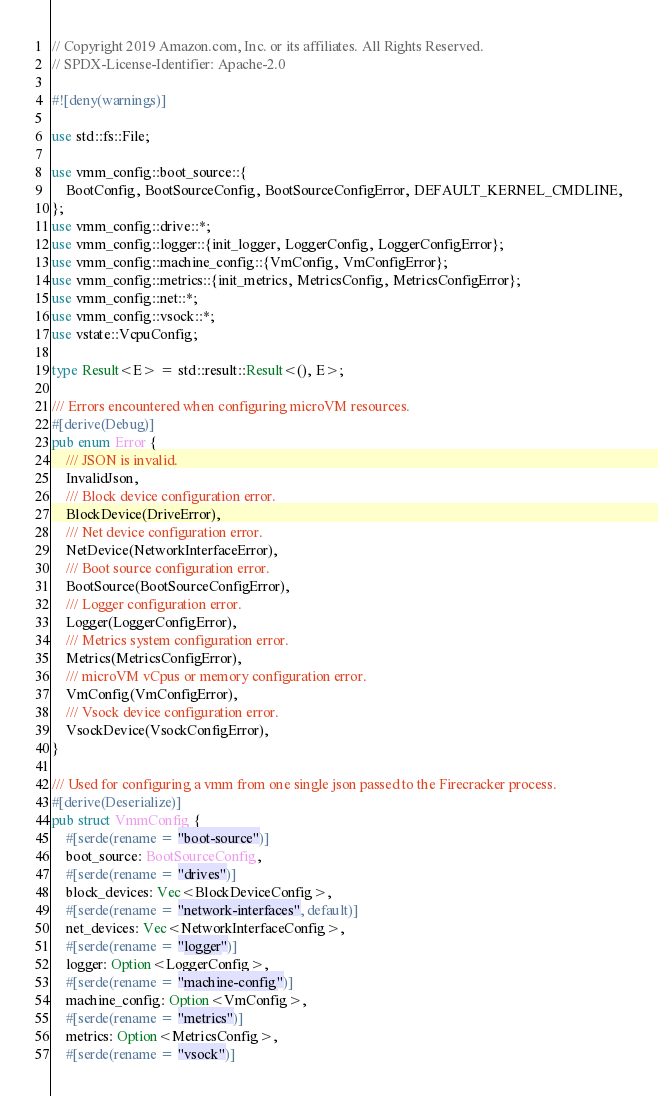<code> <loc_0><loc_0><loc_500><loc_500><_Rust_>// Copyright 2019 Amazon.com, Inc. or its affiliates. All Rights Reserved.
// SPDX-License-Identifier: Apache-2.0

#![deny(warnings)]

use std::fs::File;

use vmm_config::boot_source::{
    BootConfig, BootSourceConfig, BootSourceConfigError, DEFAULT_KERNEL_CMDLINE,
};
use vmm_config::drive::*;
use vmm_config::logger::{init_logger, LoggerConfig, LoggerConfigError};
use vmm_config::machine_config::{VmConfig, VmConfigError};
use vmm_config::metrics::{init_metrics, MetricsConfig, MetricsConfigError};
use vmm_config::net::*;
use vmm_config::vsock::*;
use vstate::VcpuConfig;

type Result<E> = std::result::Result<(), E>;

/// Errors encountered when configuring microVM resources.
#[derive(Debug)]
pub enum Error {
    /// JSON is invalid.
    InvalidJson,
    /// Block device configuration error.
    BlockDevice(DriveError),
    /// Net device configuration error.
    NetDevice(NetworkInterfaceError),
    /// Boot source configuration error.
    BootSource(BootSourceConfigError),
    /// Logger configuration error.
    Logger(LoggerConfigError),
    /// Metrics system configuration error.
    Metrics(MetricsConfigError),
    /// microVM vCpus or memory configuration error.
    VmConfig(VmConfigError),
    /// Vsock device configuration error.
    VsockDevice(VsockConfigError),
}

/// Used for configuring a vmm from one single json passed to the Firecracker process.
#[derive(Deserialize)]
pub struct VmmConfig {
    #[serde(rename = "boot-source")]
    boot_source: BootSourceConfig,
    #[serde(rename = "drives")]
    block_devices: Vec<BlockDeviceConfig>,
    #[serde(rename = "network-interfaces", default)]
    net_devices: Vec<NetworkInterfaceConfig>,
    #[serde(rename = "logger")]
    logger: Option<LoggerConfig>,
    #[serde(rename = "machine-config")]
    machine_config: Option<VmConfig>,
    #[serde(rename = "metrics")]
    metrics: Option<MetricsConfig>,
    #[serde(rename = "vsock")]</code> 